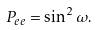Convert formula to latex. <formula><loc_0><loc_0><loc_500><loc_500>P _ { e e } = \sin ^ { 2 } \omega .</formula> 